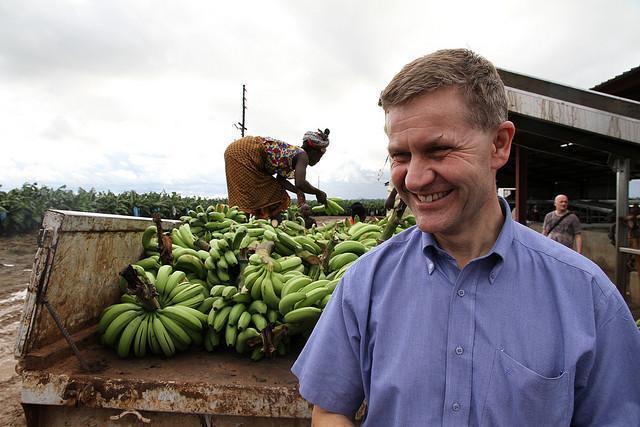How many people can you see?
Give a very brief answer. 2. How many bananas are there?
Give a very brief answer. 4. 